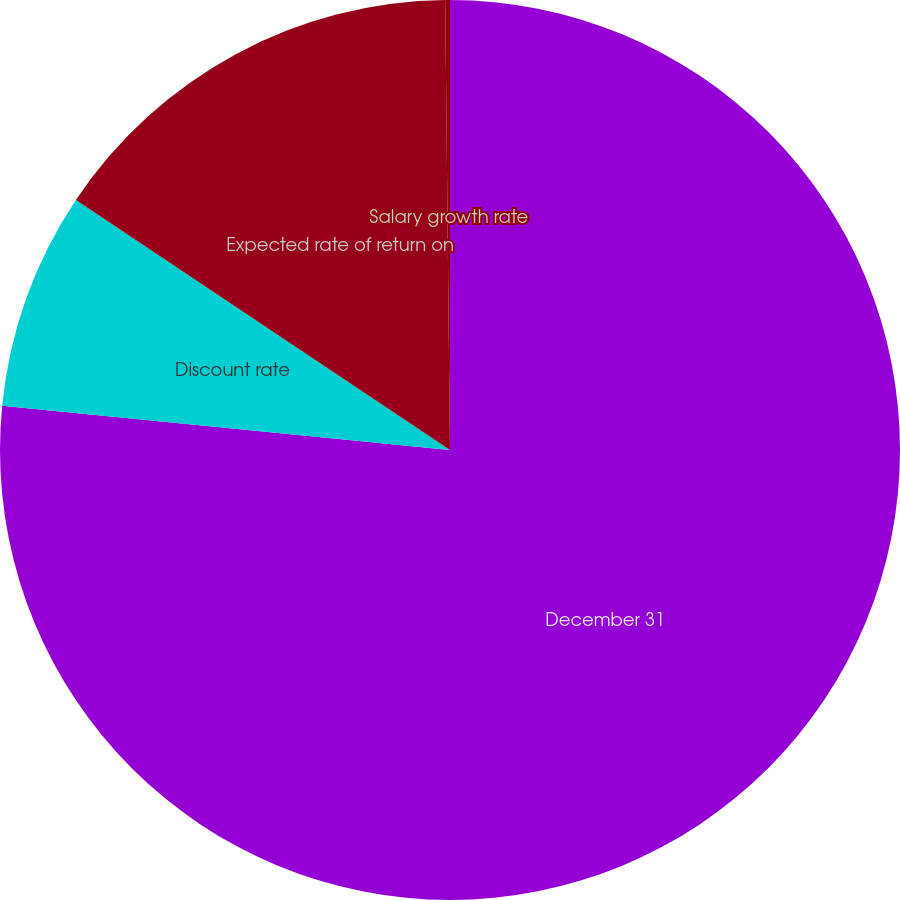<chart> <loc_0><loc_0><loc_500><loc_500><pie_chart><fcel>December 31<fcel>Discount rate<fcel>Expected rate of return on<fcel>Salary growth rate<nl><fcel>76.57%<fcel>7.81%<fcel>15.45%<fcel>0.17%<nl></chart> 